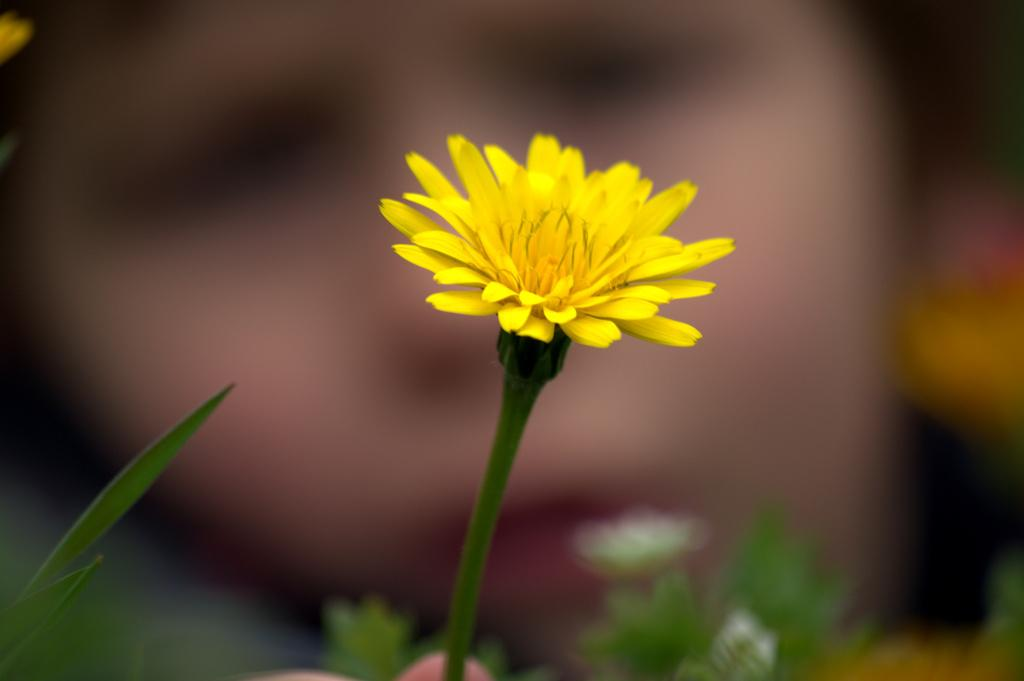What is the main subject of the image? There is a flower in the image. What parts of the flower are visible? There is a stem and leaves in the image. How would you describe the background of the image? The background has a blurred view. What type of marble is used to decorate the flower in the image? There is no marble present in the image; it features a flower with a stem and leaves. What flavor of paper can be seen in the image? There is no paper present in the image, only a flower with a stem and leaves. 